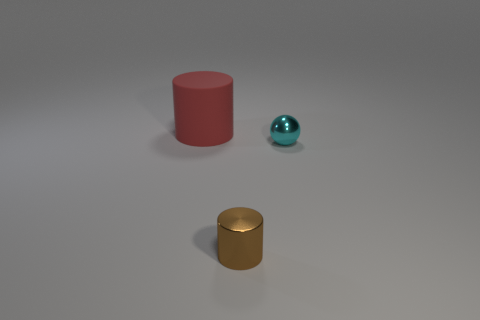What number of blue things are rubber things or spheres?
Ensure brevity in your answer.  0. Is the number of cylinders that are right of the red object less than the number of things behind the shiny cylinder?
Your answer should be compact. Yes. Is there a metal cylinder that has the same size as the cyan object?
Make the answer very short. Yes. Do the cylinder that is in front of the red matte cylinder and the large matte thing have the same size?
Offer a terse response. No. Are there more small metallic cylinders than metal objects?
Offer a terse response. No. Is there another thing that has the same shape as the large matte thing?
Provide a succinct answer. Yes. There is a big red thing that is behind the tiny sphere; what shape is it?
Your answer should be compact. Cylinder. There is a tiny shiny thing to the left of the small metal object to the right of the brown metal cylinder; what number of tiny cyan shiny spheres are in front of it?
Offer a terse response. 0. How many other objects are the same shape as the brown metallic thing?
Offer a terse response. 1. How many other objects are the same material as the small brown cylinder?
Ensure brevity in your answer.  1. 